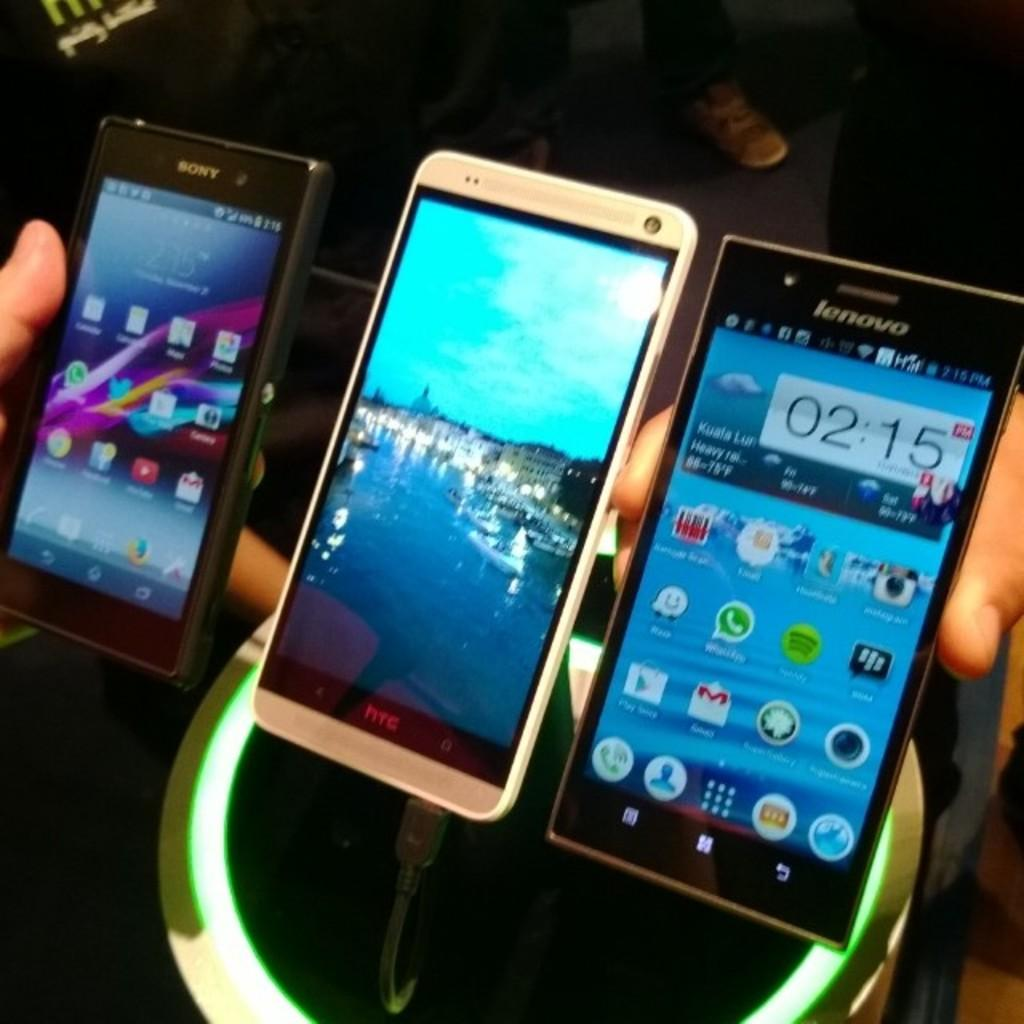<image>
Relay a brief, clear account of the picture shown. The lenovo logo can be seen on a phone. 